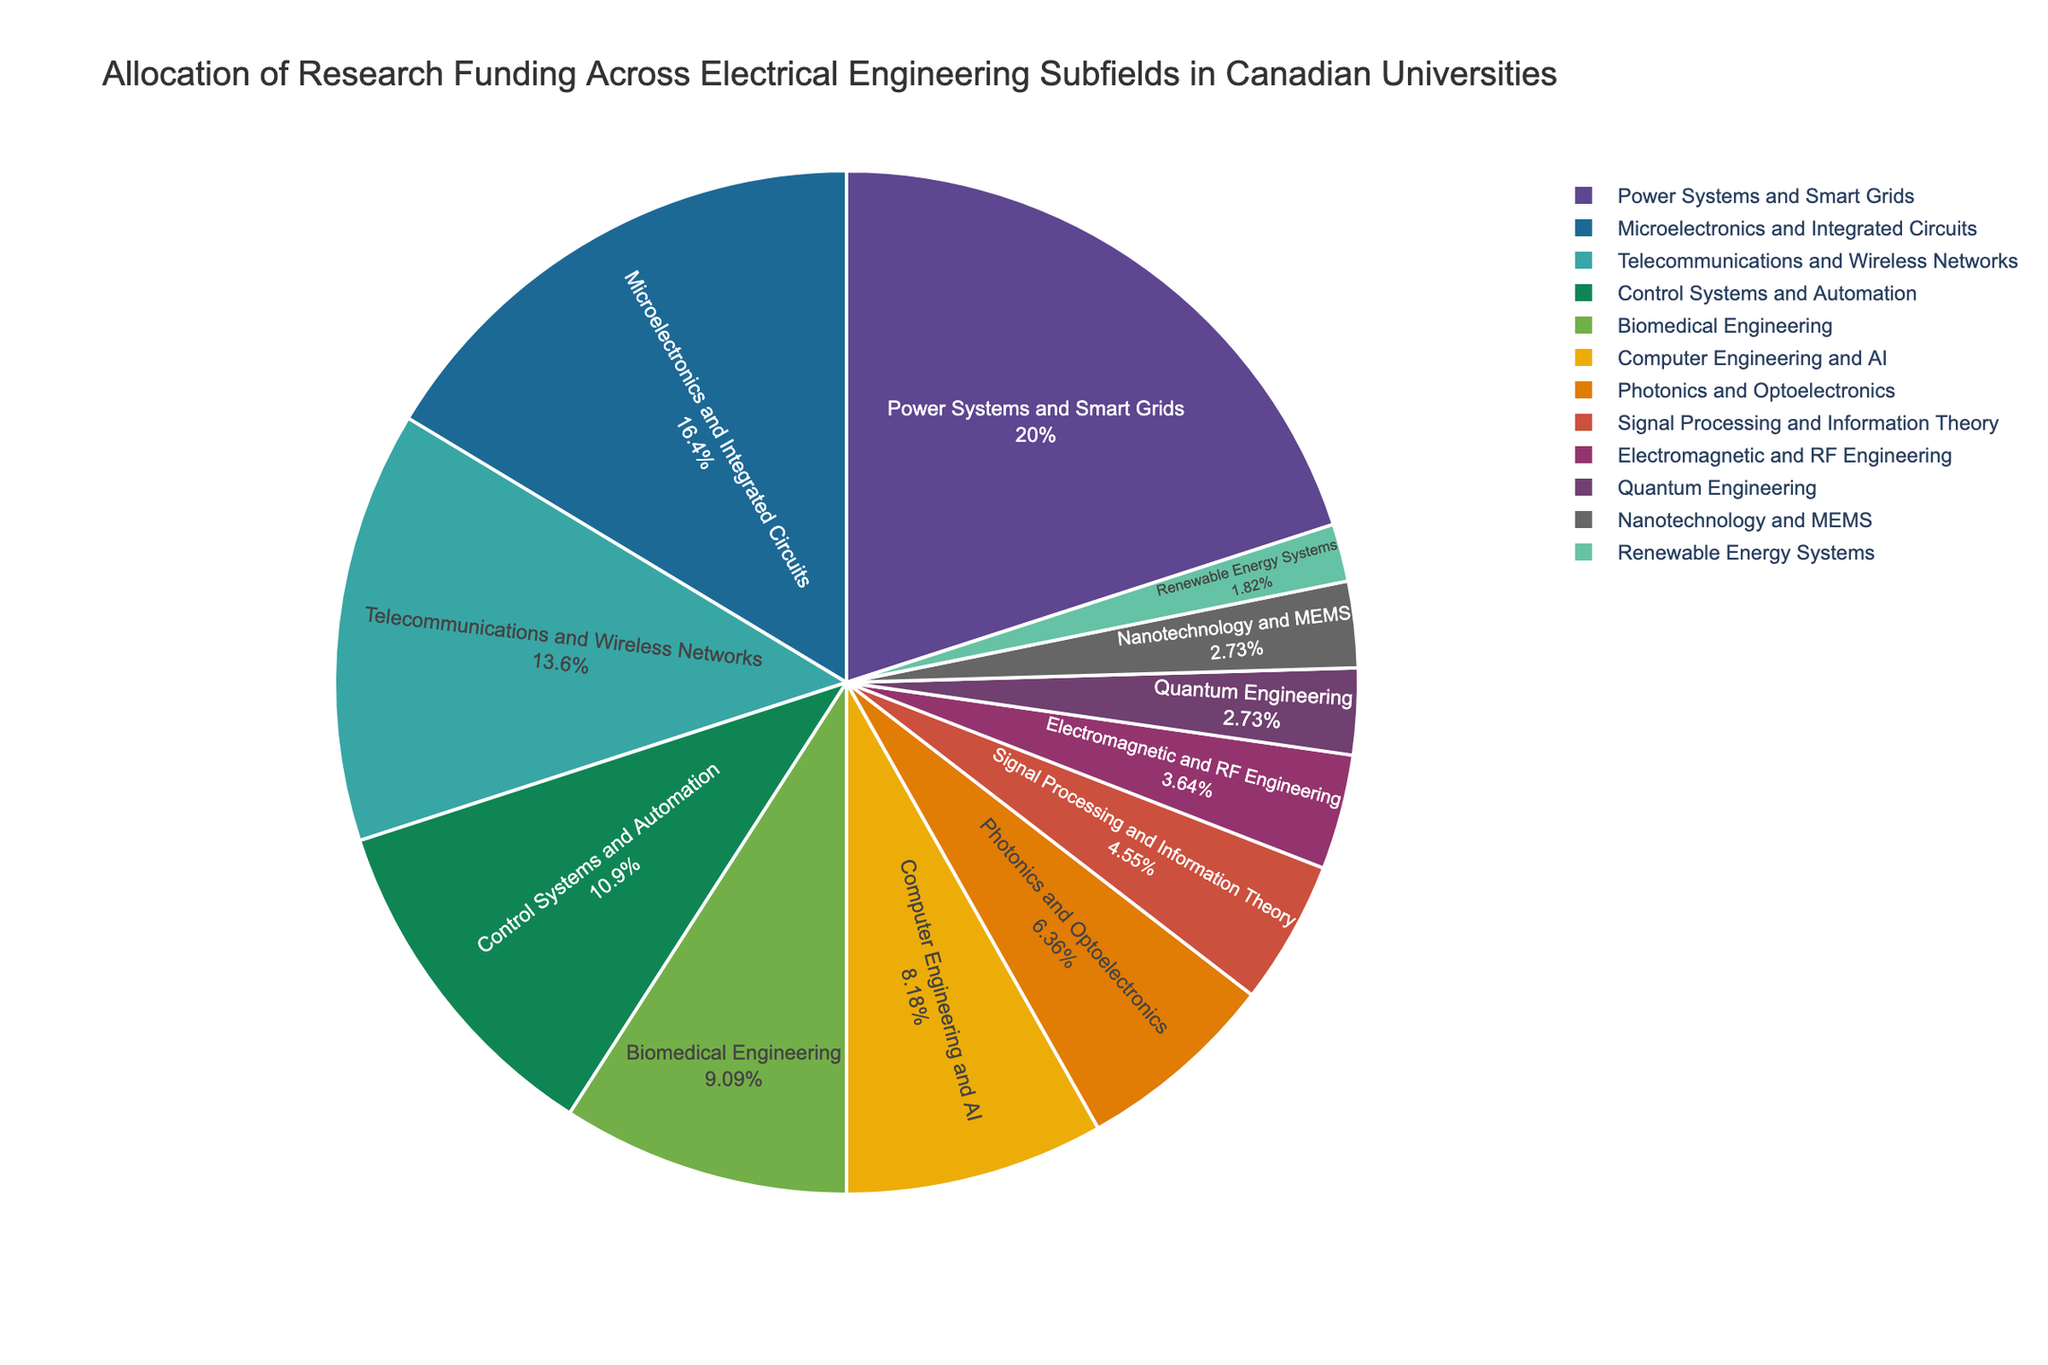What's the subfield with the highest research funding allocation? The subfield with the largest slice in the pie chart represents the highest research funding allocation. Comparing the sizes, "Power Systems and Smart Grids" is the largest slice.
Answer: Power Systems and Smart Grids What percentage of the total research funding is allocated to Microelectronics and Integrated Circuits and Control Systems and Automation together? To find the combined percentage, add the funding percentages of both subfields: 18% (Microelectronics and Integrated Circuits) + 12% (Control Systems and Automation).
Answer: 30% Which subfield receives more funding: Telecommunications and Wireless Networks or Biomedical Engineering? Compare the funding percentages for both subfields: 15% (Telecommunications and Wireless Networks) vs. 10% (Biomedical Engineering).
Answer: Telecommunications and Wireless Networks How much more funding does Power Systems and Smart Grids receive compared to Quantum Engineering? Subtract the percentage of Quantum Engineering from Power Systems and Smart Grids: 22% - 3%.
Answer: 19% What is the cumulative percentage of research funding allocated to subfields with less than 5% each? Add the funding percentages of the subfields with less than 5%: Quantum Engineering (3%) + Nanotechnology and MEMS (3%) + Renewable Energy Systems (2%) + Electromagnetic and RF Engineering (4%).
Answer: 12% Are there more subfields with funding percentages above or below 10%? Count the subfields with percentages above 10% and below 10%. Above 10%: Power Systems and Smart Grids, Microelectronics and Integrated Circuits, Telecommunications and Wireless Networks, Control Systems and Automation (4). Below 10%: Biomedical Engineering, Computer Engineering and AI, Photonics and Optoelectronics, Signal Processing and Information Theory, Electromagnetic and RF Engineering, Quantum Engineering, Nanotechnology and MEMS, Renewable Energy Systems (8).
Answer: Below 10% How does the funding for Photonics and Optoelectronics compare to Computer Engineering and AI? Compare their funding percentages: 7% (Photonics and Optoelectronics) vs. 9% (Computer Engineering and AI).
Answer: Photonics and Optoelectronics receives less funding What fraction of the total funding is allocated to Signal Processing and Information Theory? The percentage given directly indicates this value: Signal Processing and Information Theory has 5%. To convert this to a fraction: 5/100 = 1/20.
Answer: 1/20 If the funding for Control Systems and Automation were to increase by 3%, what would its new funding percentage be? Add 3% to the current funding percentage of Control Systems and Automation: 12% + 3%.
Answer: 15% What is the difference in funding percentage between the subfield with the highest funding and the one with the lowest funding? Subtract the percentage of the subfield with the lowest funding (Renewable Energy Systems, 2%) from the highest (Power Systems and Smart Grids, 22%): 22% - 2%.
Answer: 20% 